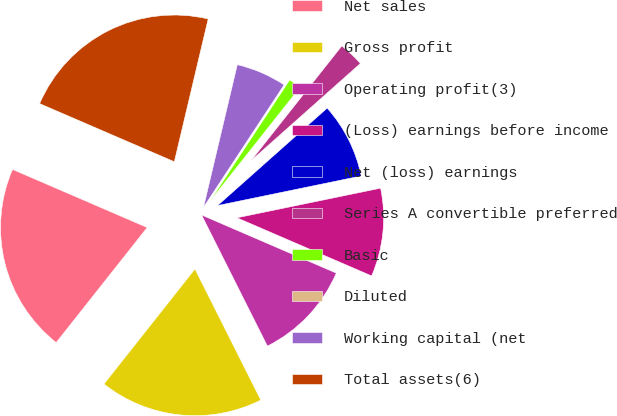<chart> <loc_0><loc_0><loc_500><loc_500><pie_chart><fcel>Net sales<fcel>Gross profit<fcel>Operating profit(3)<fcel>(Loss) earnings before income<fcel>Net (loss) earnings<fcel>Series A convertible preferred<fcel>Basic<fcel>Diluted<fcel>Working capital (net<fcel>Total assets(6)<nl><fcel>20.83%<fcel>18.06%<fcel>11.11%<fcel>9.72%<fcel>8.33%<fcel>2.78%<fcel>1.39%<fcel>0.0%<fcel>5.56%<fcel>22.22%<nl></chart> 